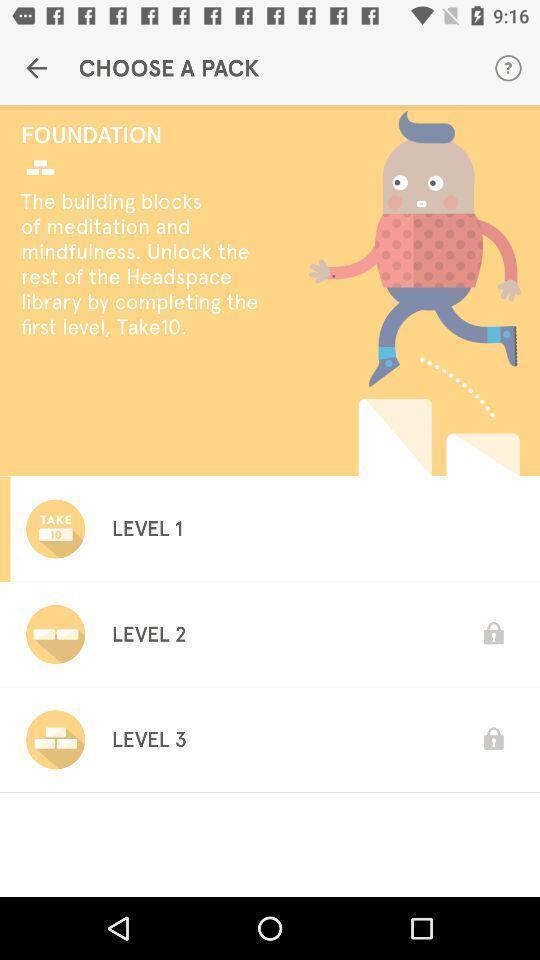What details can you identify in this image? Page to choose a meditation pack. 